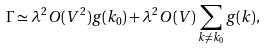Convert formula to latex. <formula><loc_0><loc_0><loc_500><loc_500>\Gamma \simeq \lambda ^ { 2 } O ( V ^ { 2 } ) g ( k _ { 0 } ) + \lambda ^ { 2 } O ( V ) \sum _ { k \neq k _ { 0 } } g ( k ) ,</formula> 